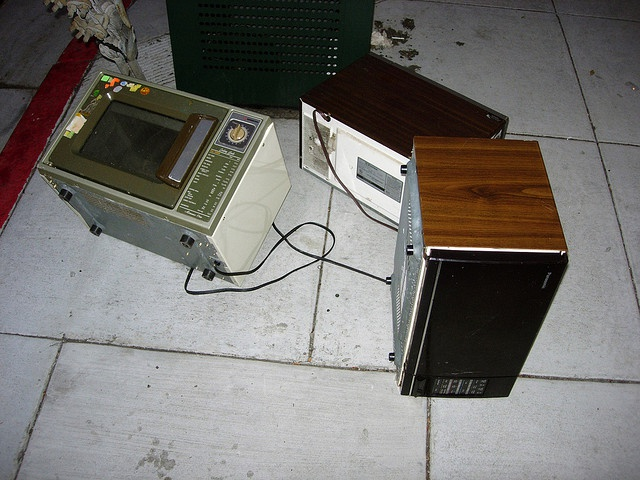Describe the objects in this image and their specific colors. I can see microwave in black, maroon, gray, and darkgray tones, microwave in black, gray, darkgray, and darkgreen tones, and microwave in black, lightgray, darkgray, and gray tones in this image. 